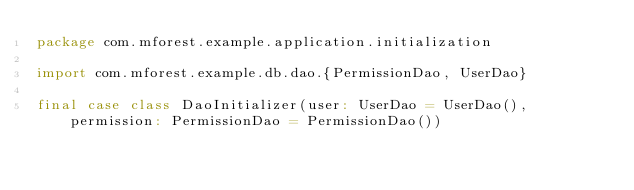Convert code to text. <code><loc_0><loc_0><loc_500><loc_500><_Scala_>package com.mforest.example.application.initialization

import com.mforest.example.db.dao.{PermissionDao, UserDao}

final case class DaoInitializer(user: UserDao = UserDao(), permission: PermissionDao = PermissionDao())
</code> 